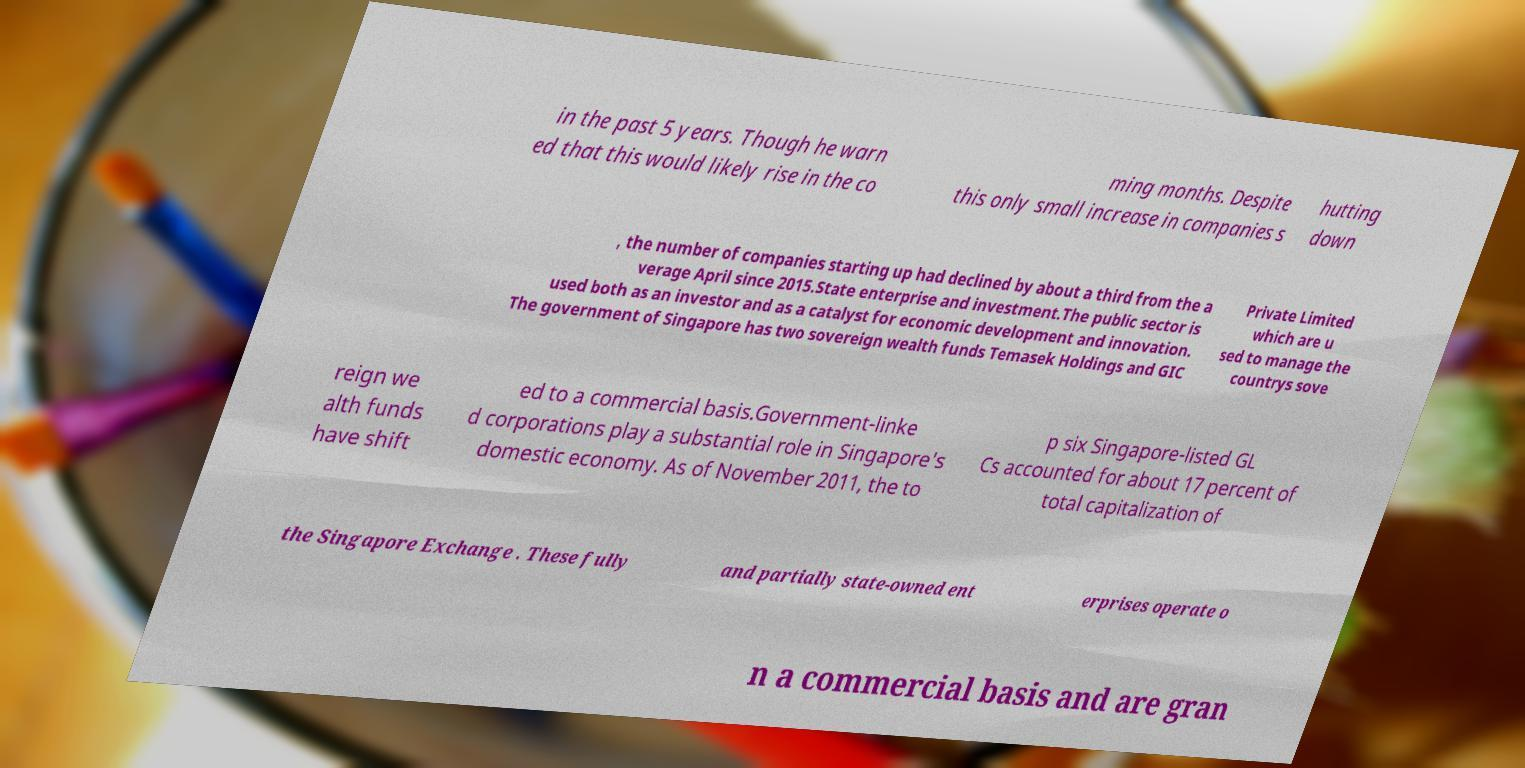Could you assist in decoding the text presented in this image and type it out clearly? in the past 5 years. Though he warn ed that this would likely rise in the co ming months. Despite this only small increase in companies s hutting down , the number of companies starting up had declined by about a third from the a verage April since 2015.State enterprise and investment.The public sector is used both as an investor and as a catalyst for economic development and innovation. The government of Singapore has two sovereign wealth funds Temasek Holdings and GIC Private Limited which are u sed to manage the countrys sove reign we alth funds have shift ed to a commercial basis.Government-linke d corporations play a substantial role in Singapore's domestic economy. As of November 2011, the to p six Singapore-listed GL Cs accounted for about 17 percent of total capitalization of the Singapore Exchange . These fully and partially state-owned ent erprises operate o n a commercial basis and are gran 